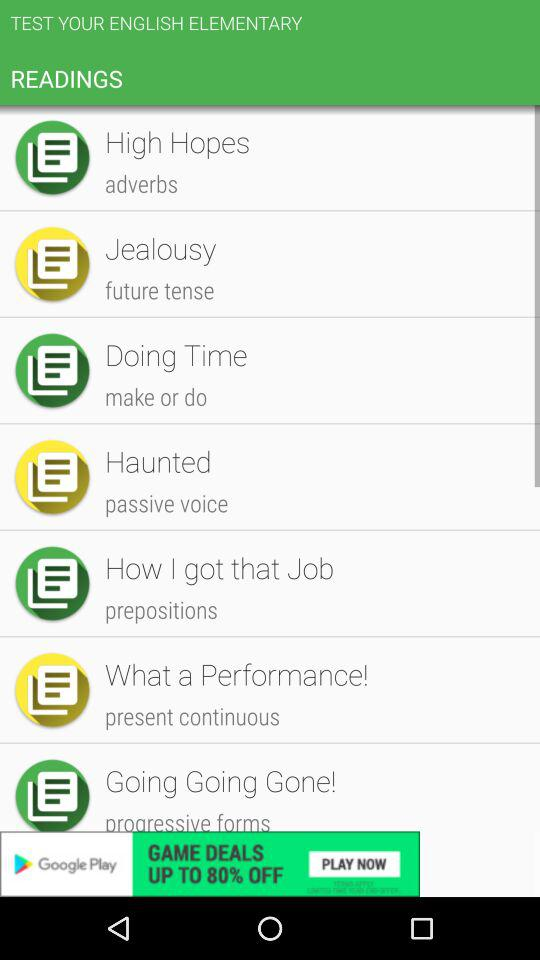Write a sentence of passive voice?
When the provided information is insufficient, respond with <no answer>. <no answer> 